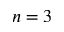Convert formula to latex. <formula><loc_0><loc_0><loc_500><loc_500>n = 3</formula> 